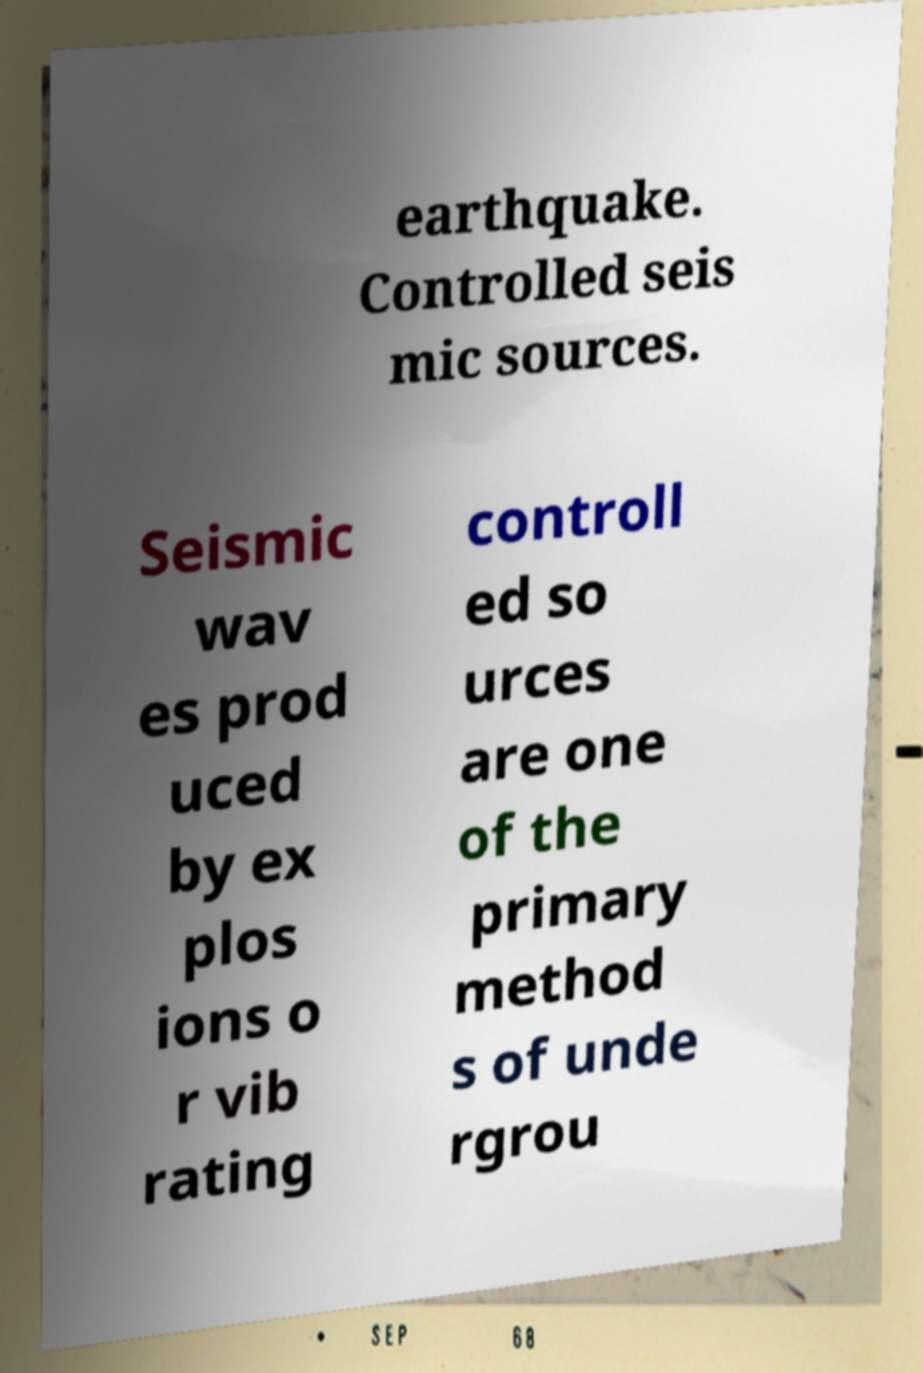Could you extract and type out the text from this image? earthquake. Controlled seis mic sources. Seismic wav es prod uced by ex plos ions o r vib rating controll ed so urces are one of the primary method s of unde rgrou 